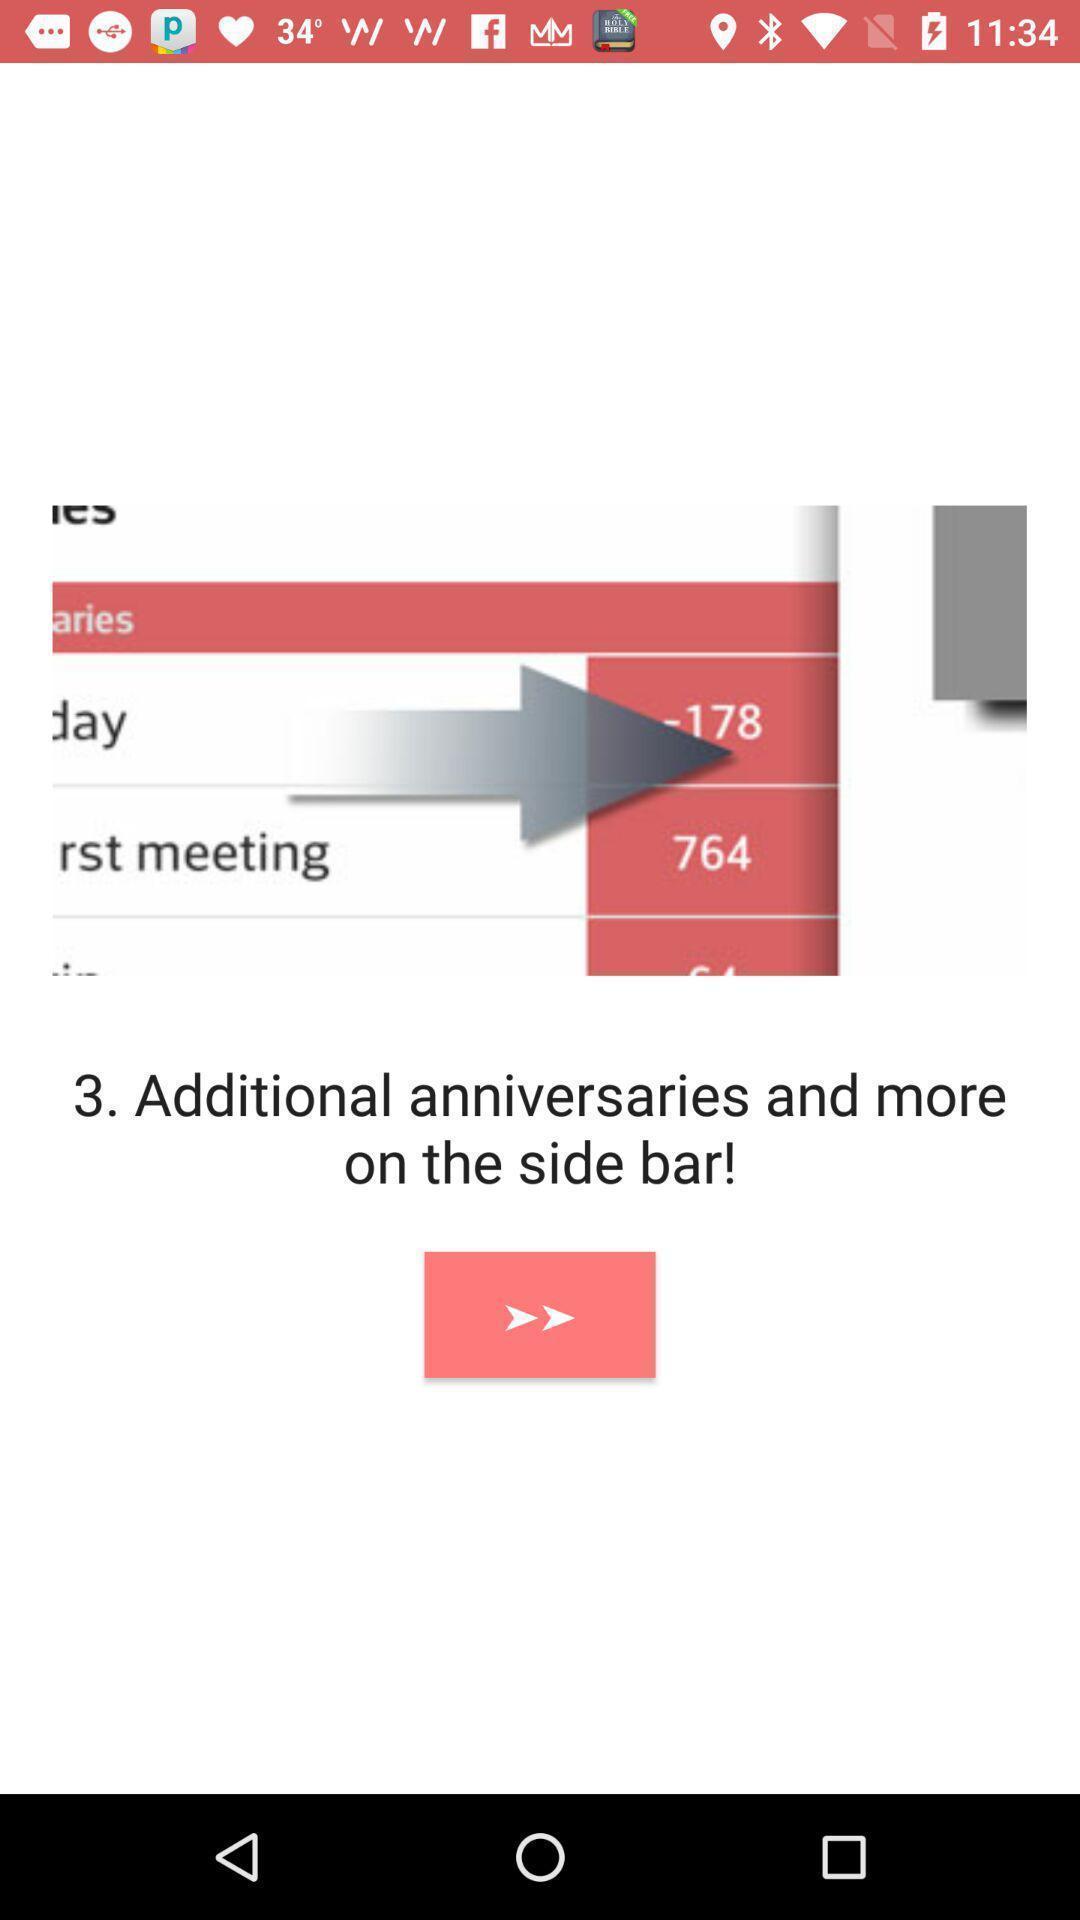Please provide a description for this image. Page with instruction for checking additional anniversaries. 